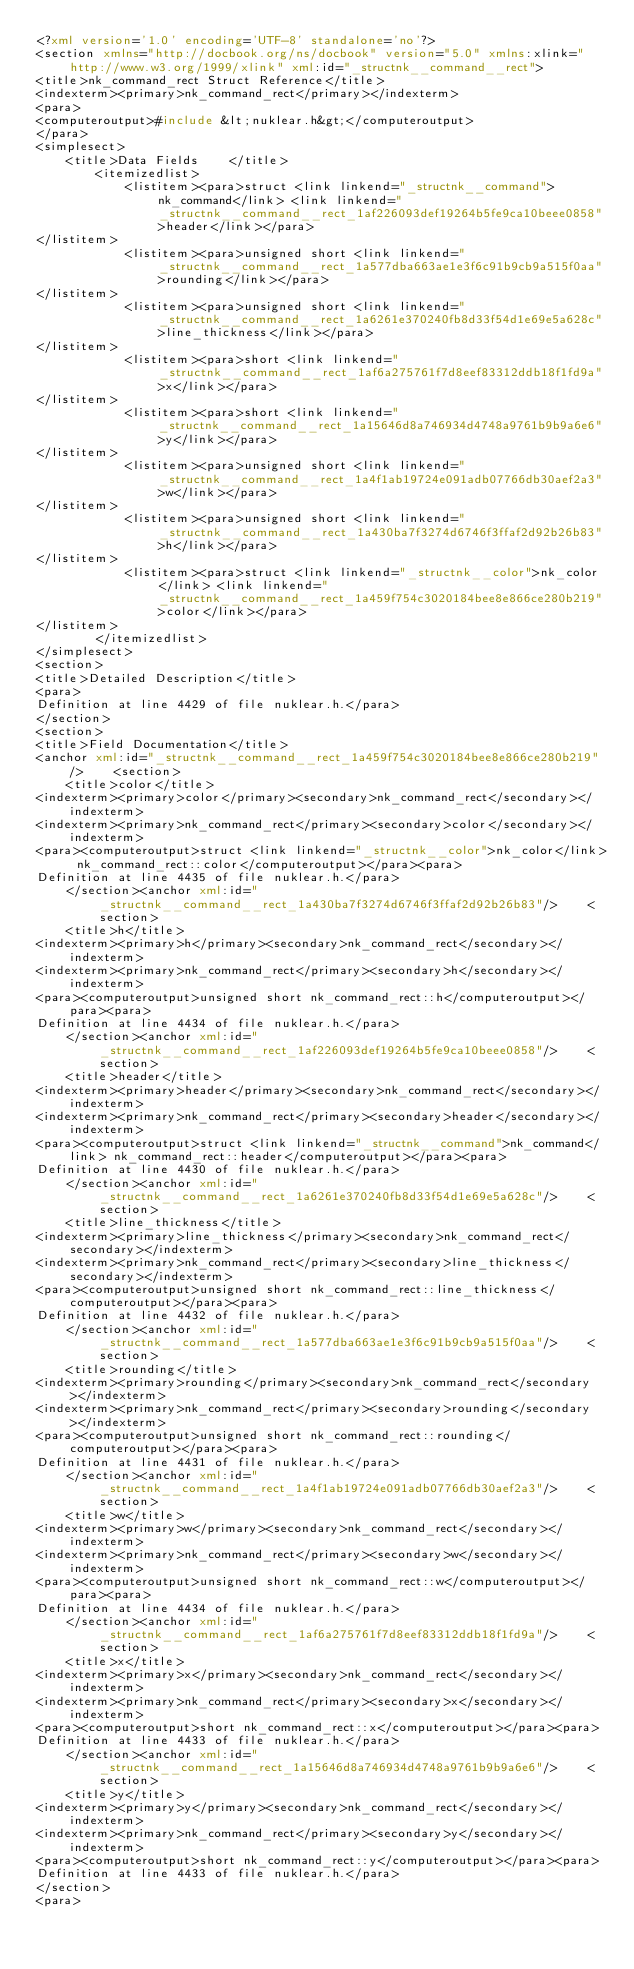Convert code to text. <code><loc_0><loc_0><loc_500><loc_500><_XML_><?xml version='1.0' encoding='UTF-8' standalone='no'?>
<section xmlns="http://docbook.org/ns/docbook" version="5.0" xmlns:xlink="http://www.w3.org/1999/xlink" xml:id="_structnk__command__rect">
<title>nk_command_rect Struct Reference</title>
<indexterm><primary>nk_command_rect</primary></indexterm>
<para>
<computeroutput>#include &lt;nuklear.h&gt;</computeroutput>
</para>
<simplesect>
    <title>Data Fields    </title>
        <itemizedlist>
            <listitem><para>struct <link linkend="_structnk__command">nk_command</link> <link linkend="_structnk__command__rect_1af226093def19264b5fe9ca10beee0858">header</link></para>
</listitem>
            <listitem><para>unsigned short <link linkend="_structnk__command__rect_1a577dba663ae1e3f6c91b9cb9a515f0aa">rounding</link></para>
</listitem>
            <listitem><para>unsigned short <link linkend="_structnk__command__rect_1a6261e370240fb8d33f54d1e69e5a628c">line_thickness</link></para>
</listitem>
            <listitem><para>short <link linkend="_structnk__command__rect_1af6a275761f7d8eef83312ddb18f1fd9a">x</link></para>
</listitem>
            <listitem><para>short <link linkend="_structnk__command__rect_1a15646d8a746934d4748a9761b9b9a6e6">y</link></para>
</listitem>
            <listitem><para>unsigned short <link linkend="_structnk__command__rect_1a4f1ab19724e091adb07766db30aef2a3">w</link></para>
</listitem>
            <listitem><para>unsigned short <link linkend="_structnk__command__rect_1a430ba7f3274d6746f3ffaf2d92b26b83">h</link></para>
</listitem>
            <listitem><para>struct <link linkend="_structnk__color">nk_color</link> <link linkend="_structnk__command__rect_1a459f754c3020184bee8e866ce280b219">color</link></para>
</listitem>
        </itemizedlist>
</simplesect>
<section>
<title>Detailed Description</title>
<para>
Definition at line 4429 of file nuklear.h.</para>
</section>
<section>
<title>Field Documentation</title>
<anchor xml:id="_structnk__command__rect_1a459f754c3020184bee8e866ce280b219"/>    <section>
    <title>color</title>
<indexterm><primary>color</primary><secondary>nk_command_rect</secondary></indexterm>
<indexterm><primary>nk_command_rect</primary><secondary>color</secondary></indexterm>
<para><computeroutput>struct <link linkend="_structnk__color">nk_color</link> nk_command_rect::color</computeroutput></para><para>
Definition at line 4435 of file nuklear.h.</para>
    </section><anchor xml:id="_structnk__command__rect_1a430ba7f3274d6746f3ffaf2d92b26b83"/>    <section>
    <title>h</title>
<indexterm><primary>h</primary><secondary>nk_command_rect</secondary></indexterm>
<indexterm><primary>nk_command_rect</primary><secondary>h</secondary></indexterm>
<para><computeroutput>unsigned short nk_command_rect::h</computeroutput></para><para>
Definition at line 4434 of file nuklear.h.</para>
    </section><anchor xml:id="_structnk__command__rect_1af226093def19264b5fe9ca10beee0858"/>    <section>
    <title>header</title>
<indexterm><primary>header</primary><secondary>nk_command_rect</secondary></indexterm>
<indexterm><primary>nk_command_rect</primary><secondary>header</secondary></indexterm>
<para><computeroutput>struct <link linkend="_structnk__command">nk_command</link> nk_command_rect::header</computeroutput></para><para>
Definition at line 4430 of file nuklear.h.</para>
    </section><anchor xml:id="_structnk__command__rect_1a6261e370240fb8d33f54d1e69e5a628c"/>    <section>
    <title>line_thickness</title>
<indexterm><primary>line_thickness</primary><secondary>nk_command_rect</secondary></indexterm>
<indexterm><primary>nk_command_rect</primary><secondary>line_thickness</secondary></indexterm>
<para><computeroutput>unsigned short nk_command_rect::line_thickness</computeroutput></para><para>
Definition at line 4432 of file nuklear.h.</para>
    </section><anchor xml:id="_structnk__command__rect_1a577dba663ae1e3f6c91b9cb9a515f0aa"/>    <section>
    <title>rounding</title>
<indexterm><primary>rounding</primary><secondary>nk_command_rect</secondary></indexterm>
<indexterm><primary>nk_command_rect</primary><secondary>rounding</secondary></indexterm>
<para><computeroutput>unsigned short nk_command_rect::rounding</computeroutput></para><para>
Definition at line 4431 of file nuklear.h.</para>
    </section><anchor xml:id="_structnk__command__rect_1a4f1ab19724e091adb07766db30aef2a3"/>    <section>
    <title>w</title>
<indexterm><primary>w</primary><secondary>nk_command_rect</secondary></indexterm>
<indexterm><primary>nk_command_rect</primary><secondary>w</secondary></indexterm>
<para><computeroutput>unsigned short nk_command_rect::w</computeroutput></para><para>
Definition at line 4434 of file nuklear.h.</para>
    </section><anchor xml:id="_structnk__command__rect_1af6a275761f7d8eef83312ddb18f1fd9a"/>    <section>
    <title>x</title>
<indexterm><primary>x</primary><secondary>nk_command_rect</secondary></indexterm>
<indexterm><primary>nk_command_rect</primary><secondary>x</secondary></indexterm>
<para><computeroutput>short nk_command_rect::x</computeroutput></para><para>
Definition at line 4433 of file nuklear.h.</para>
    </section><anchor xml:id="_structnk__command__rect_1a15646d8a746934d4748a9761b9b9a6e6"/>    <section>
    <title>y</title>
<indexterm><primary>y</primary><secondary>nk_command_rect</secondary></indexterm>
<indexterm><primary>nk_command_rect</primary><secondary>y</secondary></indexterm>
<para><computeroutput>short nk_command_rect::y</computeroutput></para><para>
Definition at line 4433 of file nuklear.h.</para>
</section>
<para></code> 